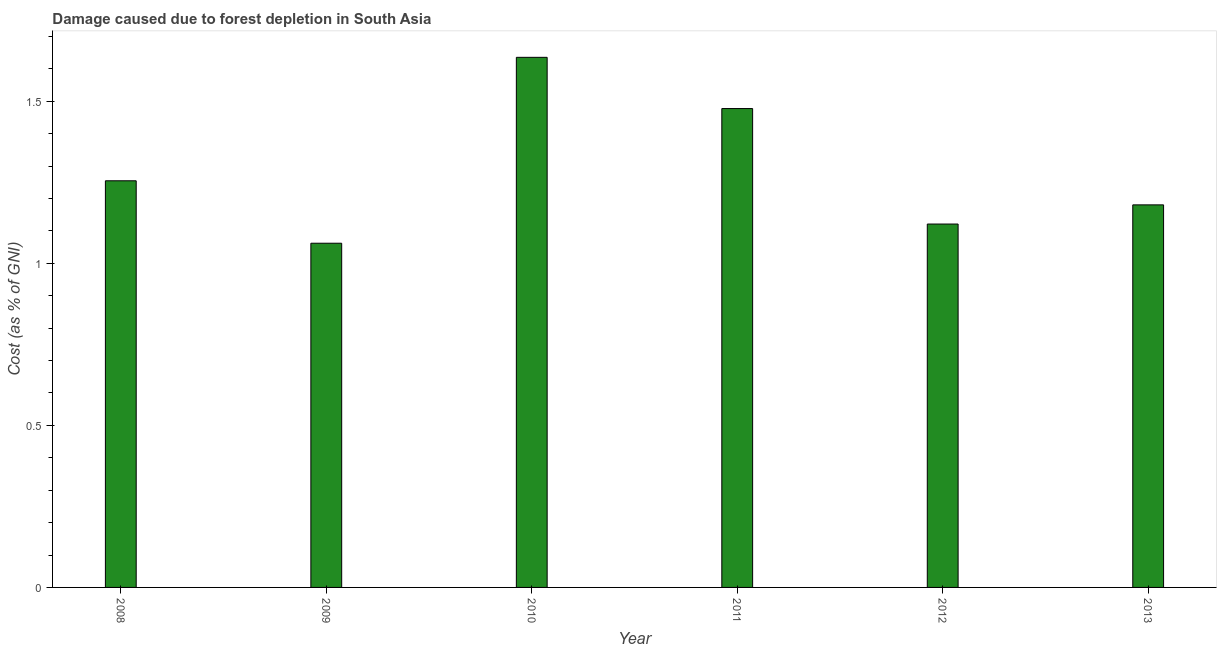What is the title of the graph?
Provide a succinct answer. Damage caused due to forest depletion in South Asia. What is the label or title of the Y-axis?
Give a very brief answer. Cost (as % of GNI). What is the damage caused due to forest depletion in 2010?
Your answer should be very brief. 1.64. Across all years, what is the maximum damage caused due to forest depletion?
Keep it short and to the point. 1.64. Across all years, what is the minimum damage caused due to forest depletion?
Provide a short and direct response. 1.06. In which year was the damage caused due to forest depletion maximum?
Your response must be concise. 2010. What is the sum of the damage caused due to forest depletion?
Offer a very short reply. 7.73. What is the difference between the damage caused due to forest depletion in 2009 and 2010?
Offer a terse response. -0.57. What is the average damage caused due to forest depletion per year?
Make the answer very short. 1.29. What is the median damage caused due to forest depletion?
Your response must be concise. 1.22. Do a majority of the years between 2011 and 2010 (inclusive) have damage caused due to forest depletion greater than 0.3 %?
Keep it short and to the point. No. What is the ratio of the damage caused due to forest depletion in 2009 to that in 2011?
Offer a very short reply. 0.72. Is the difference between the damage caused due to forest depletion in 2008 and 2009 greater than the difference between any two years?
Your response must be concise. No. What is the difference between the highest and the second highest damage caused due to forest depletion?
Your answer should be compact. 0.16. What is the difference between the highest and the lowest damage caused due to forest depletion?
Keep it short and to the point. 0.57. In how many years, is the damage caused due to forest depletion greater than the average damage caused due to forest depletion taken over all years?
Your answer should be very brief. 2. What is the difference between two consecutive major ticks on the Y-axis?
Keep it short and to the point. 0.5. What is the Cost (as % of GNI) of 2008?
Provide a succinct answer. 1.25. What is the Cost (as % of GNI) of 2009?
Offer a very short reply. 1.06. What is the Cost (as % of GNI) in 2010?
Offer a terse response. 1.64. What is the Cost (as % of GNI) in 2011?
Offer a terse response. 1.48. What is the Cost (as % of GNI) of 2012?
Your answer should be very brief. 1.12. What is the Cost (as % of GNI) in 2013?
Offer a terse response. 1.18. What is the difference between the Cost (as % of GNI) in 2008 and 2009?
Give a very brief answer. 0.19. What is the difference between the Cost (as % of GNI) in 2008 and 2010?
Make the answer very short. -0.38. What is the difference between the Cost (as % of GNI) in 2008 and 2011?
Offer a very short reply. -0.22. What is the difference between the Cost (as % of GNI) in 2008 and 2012?
Your answer should be compact. 0.13. What is the difference between the Cost (as % of GNI) in 2008 and 2013?
Ensure brevity in your answer.  0.07. What is the difference between the Cost (as % of GNI) in 2009 and 2010?
Provide a short and direct response. -0.57. What is the difference between the Cost (as % of GNI) in 2009 and 2011?
Your response must be concise. -0.42. What is the difference between the Cost (as % of GNI) in 2009 and 2012?
Provide a succinct answer. -0.06. What is the difference between the Cost (as % of GNI) in 2009 and 2013?
Give a very brief answer. -0.12. What is the difference between the Cost (as % of GNI) in 2010 and 2011?
Make the answer very short. 0.16. What is the difference between the Cost (as % of GNI) in 2010 and 2012?
Make the answer very short. 0.51. What is the difference between the Cost (as % of GNI) in 2010 and 2013?
Provide a short and direct response. 0.46. What is the difference between the Cost (as % of GNI) in 2011 and 2012?
Ensure brevity in your answer.  0.36. What is the difference between the Cost (as % of GNI) in 2011 and 2013?
Keep it short and to the point. 0.3. What is the difference between the Cost (as % of GNI) in 2012 and 2013?
Keep it short and to the point. -0.06. What is the ratio of the Cost (as % of GNI) in 2008 to that in 2009?
Offer a terse response. 1.18. What is the ratio of the Cost (as % of GNI) in 2008 to that in 2010?
Keep it short and to the point. 0.77. What is the ratio of the Cost (as % of GNI) in 2008 to that in 2011?
Ensure brevity in your answer.  0.85. What is the ratio of the Cost (as % of GNI) in 2008 to that in 2012?
Offer a terse response. 1.12. What is the ratio of the Cost (as % of GNI) in 2008 to that in 2013?
Your answer should be compact. 1.06. What is the ratio of the Cost (as % of GNI) in 2009 to that in 2010?
Give a very brief answer. 0.65. What is the ratio of the Cost (as % of GNI) in 2009 to that in 2011?
Your answer should be very brief. 0.72. What is the ratio of the Cost (as % of GNI) in 2009 to that in 2012?
Give a very brief answer. 0.95. What is the ratio of the Cost (as % of GNI) in 2010 to that in 2011?
Provide a short and direct response. 1.11. What is the ratio of the Cost (as % of GNI) in 2010 to that in 2012?
Provide a succinct answer. 1.46. What is the ratio of the Cost (as % of GNI) in 2010 to that in 2013?
Offer a very short reply. 1.39. What is the ratio of the Cost (as % of GNI) in 2011 to that in 2012?
Keep it short and to the point. 1.32. What is the ratio of the Cost (as % of GNI) in 2011 to that in 2013?
Your answer should be very brief. 1.25. 